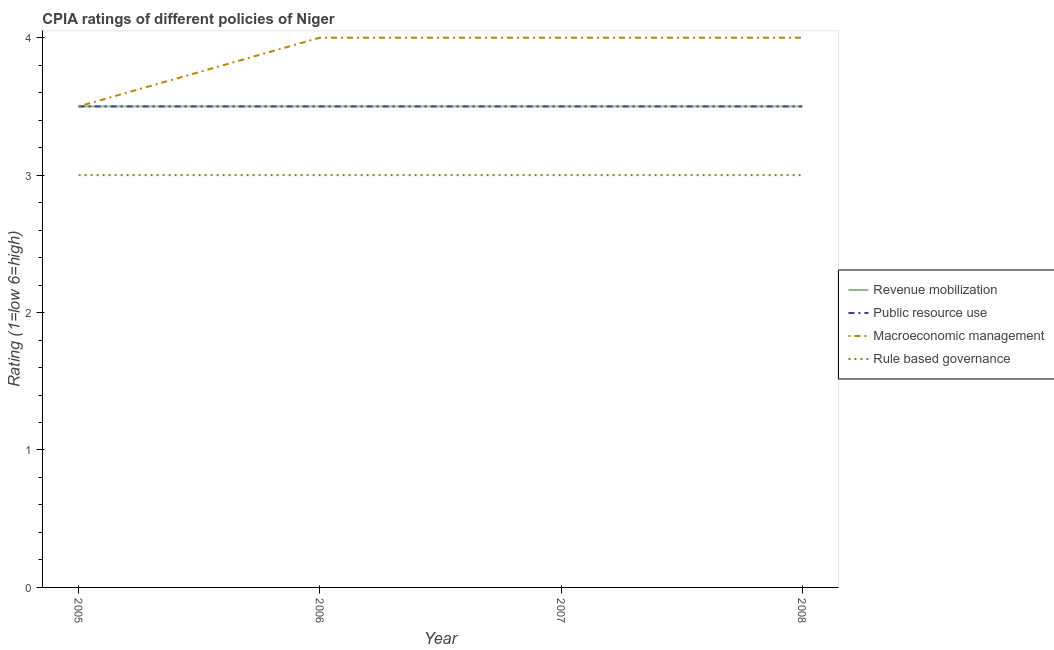How many different coloured lines are there?
Keep it short and to the point. 4. What is the cpia rating of rule based governance in 2007?
Offer a very short reply. 3. Across all years, what is the maximum cpia rating of macroeconomic management?
Keep it short and to the point. 4. What is the difference between the cpia rating of macroeconomic management in 2006 and that in 2008?
Provide a short and direct response. 0. What is the average cpia rating of revenue mobilization per year?
Offer a very short reply. 3.5. In the year 2005, what is the difference between the cpia rating of revenue mobilization and cpia rating of public resource use?
Your answer should be very brief. 0. In how many years, is the cpia rating of macroeconomic management greater than 2.8?
Provide a succinct answer. 4. What is the ratio of the cpia rating of revenue mobilization in 2007 to that in 2008?
Your answer should be very brief. 1. What is the difference between the highest and the second highest cpia rating of macroeconomic management?
Your answer should be compact. 0. Is the sum of the cpia rating of rule based governance in 2006 and 2008 greater than the maximum cpia rating of macroeconomic management across all years?
Your response must be concise. Yes. Is it the case that in every year, the sum of the cpia rating of rule based governance and cpia rating of macroeconomic management is greater than the sum of cpia rating of public resource use and cpia rating of revenue mobilization?
Ensure brevity in your answer.  No. Is it the case that in every year, the sum of the cpia rating of revenue mobilization and cpia rating of public resource use is greater than the cpia rating of macroeconomic management?
Give a very brief answer. Yes. How many lines are there?
Keep it short and to the point. 4. What is the difference between two consecutive major ticks on the Y-axis?
Offer a terse response. 1. Does the graph contain grids?
Offer a terse response. No. How many legend labels are there?
Make the answer very short. 4. What is the title of the graph?
Ensure brevity in your answer.  CPIA ratings of different policies of Niger. What is the Rating (1=low 6=high) in Revenue mobilization in 2005?
Keep it short and to the point. 3.5. What is the Rating (1=low 6=high) in Public resource use in 2005?
Provide a short and direct response. 3.5. What is the Rating (1=low 6=high) of Macroeconomic management in 2005?
Give a very brief answer. 3.5. What is the Rating (1=low 6=high) of Rule based governance in 2005?
Provide a succinct answer. 3. What is the Rating (1=low 6=high) in Revenue mobilization in 2006?
Ensure brevity in your answer.  3.5. What is the Rating (1=low 6=high) of Revenue mobilization in 2007?
Make the answer very short. 3.5. What is the Rating (1=low 6=high) in Public resource use in 2007?
Ensure brevity in your answer.  3.5. What is the Rating (1=low 6=high) of Macroeconomic management in 2007?
Make the answer very short. 4. What is the Rating (1=low 6=high) of Rule based governance in 2007?
Give a very brief answer. 3. What is the Rating (1=low 6=high) in Revenue mobilization in 2008?
Give a very brief answer. 3.5. What is the Rating (1=low 6=high) of Macroeconomic management in 2008?
Make the answer very short. 4. Across all years, what is the maximum Rating (1=low 6=high) in Rule based governance?
Your response must be concise. 3. Across all years, what is the minimum Rating (1=low 6=high) of Revenue mobilization?
Provide a short and direct response. 3.5. Across all years, what is the minimum Rating (1=low 6=high) in Rule based governance?
Provide a short and direct response. 3. What is the difference between the Rating (1=low 6=high) of Rule based governance in 2005 and that in 2006?
Make the answer very short. 0. What is the difference between the Rating (1=low 6=high) in Revenue mobilization in 2005 and that in 2007?
Offer a very short reply. 0. What is the difference between the Rating (1=low 6=high) in Public resource use in 2005 and that in 2007?
Offer a very short reply. 0. What is the difference between the Rating (1=low 6=high) in Revenue mobilization in 2005 and that in 2008?
Make the answer very short. 0. What is the difference between the Rating (1=low 6=high) of Public resource use in 2005 and that in 2008?
Offer a very short reply. 0. What is the difference between the Rating (1=low 6=high) in Rule based governance in 2005 and that in 2008?
Keep it short and to the point. 0. What is the difference between the Rating (1=low 6=high) of Public resource use in 2006 and that in 2007?
Give a very brief answer. 0. What is the difference between the Rating (1=low 6=high) of Rule based governance in 2006 and that in 2008?
Provide a short and direct response. 0. What is the difference between the Rating (1=low 6=high) of Revenue mobilization in 2007 and that in 2008?
Ensure brevity in your answer.  0. What is the difference between the Rating (1=low 6=high) in Public resource use in 2007 and that in 2008?
Your response must be concise. 0. What is the difference between the Rating (1=low 6=high) of Macroeconomic management in 2007 and that in 2008?
Make the answer very short. 0. What is the difference between the Rating (1=low 6=high) in Rule based governance in 2007 and that in 2008?
Keep it short and to the point. 0. What is the difference between the Rating (1=low 6=high) of Revenue mobilization in 2005 and the Rating (1=low 6=high) of Rule based governance in 2006?
Provide a short and direct response. 0.5. What is the difference between the Rating (1=low 6=high) in Public resource use in 2005 and the Rating (1=low 6=high) in Rule based governance in 2006?
Keep it short and to the point. 0.5. What is the difference between the Rating (1=low 6=high) in Macroeconomic management in 2005 and the Rating (1=low 6=high) in Rule based governance in 2006?
Offer a very short reply. 0.5. What is the difference between the Rating (1=low 6=high) in Revenue mobilization in 2005 and the Rating (1=low 6=high) in Public resource use in 2007?
Give a very brief answer. 0. What is the difference between the Rating (1=low 6=high) in Revenue mobilization in 2005 and the Rating (1=low 6=high) in Macroeconomic management in 2007?
Provide a short and direct response. -0.5. What is the difference between the Rating (1=low 6=high) in Revenue mobilization in 2005 and the Rating (1=low 6=high) in Rule based governance in 2007?
Keep it short and to the point. 0.5. What is the difference between the Rating (1=low 6=high) in Public resource use in 2005 and the Rating (1=low 6=high) in Rule based governance in 2007?
Your answer should be very brief. 0.5. What is the difference between the Rating (1=low 6=high) of Macroeconomic management in 2005 and the Rating (1=low 6=high) of Rule based governance in 2007?
Your answer should be compact. 0.5. What is the difference between the Rating (1=low 6=high) of Revenue mobilization in 2005 and the Rating (1=low 6=high) of Public resource use in 2008?
Offer a very short reply. 0. What is the difference between the Rating (1=low 6=high) in Revenue mobilization in 2005 and the Rating (1=low 6=high) in Macroeconomic management in 2008?
Provide a succinct answer. -0.5. What is the difference between the Rating (1=low 6=high) of Revenue mobilization in 2005 and the Rating (1=low 6=high) of Rule based governance in 2008?
Offer a terse response. 0.5. What is the difference between the Rating (1=low 6=high) of Public resource use in 2005 and the Rating (1=low 6=high) of Macroeconomic management in 2008?
Your response must be concise. -0.5. What is the difference between the Rating (1=low 6=high) of Revenue mobilization in 2006 and the Rating (1=low 6=high) of Public resource use in 2007?
Keep it short and to the point. 0. What is the difference between the Rating (1=low 6=high) in Public resource use in 2006 and the Rating (1=low 6=high) in Macroeconomic management in 2007?
Make the answer very short. -0.5. What is the difference between the Rating (1=low 6=high) in Macroeconomic management in 2006 and the Rating (1=low 6=high) in Rule based governance in 2007?
Make the answer very short. 1. What is the difference between the Rating (1=low 6=high) of Revenue mobilization in 2006 and the Rating (1=low 6=high) of Macroeconomic management in 2008?
Ensure brevity in your answer.  -0.5. What is the difference between the Rating (1=low 6=high) of Revenue mobilization in 2006 and the Rating (1=low 6=high) of Rule based governance in 2008?
Provide a succinct answer. 0.5. What is the difference between the Rating (1=low 6=high) of Macroeconomic management in 2006 and the Rating (1=low 6=high) of Rule based governance in 2008?
Your response must be concise. 1. What is the difference between the Rating (1=low 6=high) in Revenue mobilization in 2007 and the Rating (1=low 6=high) in Rule based governance in 2008?
Give a very brief answer. 0.5. What is the difference between the Rating (1=low 6=high) in Public resource use in 2007 and the Rating (1=low 6=high) in Rule based governance in 2008?
Make the answer very short. 0.5. What is the average Rating (1=low 6=high) in Revenue mobilization per year?
Your answer should be compact. 3.5. What is the average Rating (1=low 6=high) in Public resource use per year?
Keep it short and to the point. 3.5. What is the average Rating (1=low 6=high) of Macroeconomic management per year?
Your answer should be compact. 3.88. What is the average Rating (1=low 6=high) in Rule based governance per year?
Ensure brevity in your answer.  3. In the year 2005, what is the difference between the Rating (1=low 6=high) in Revenue mobilization and Rating (1=low 6=high) in Rule based governance?
Provide a short and direct response. 0.5. In the year 2006, what is the difference between the Rating (1=low 6=high) in Revenue mobilization and Rating (1=low 6=high) in Public resource use?
Make the answer very short. 0. In the year 2006, what is the difference between the Rating (1=low 6=high) of Revenue mobilization and Rating (1=low 6=high) of Rule based governance?
Offer a very short reply. 0.5. In the year 2006, what is the difference between the Rating (1=low 6=high) in Public resource use and Rating (1=low 6=high) in Macroeconomic management?
Offer a terse response. -0.5. In the year 2006, what is the difference between the Rating (1=low 6=high) in Macroeconomic management and Rating (1=low 6=high) in Rule based governance?
Make the answer very short. 1. In the year 2007, what is the difference between the Rating (1=low 6=high) of Public resource use and Rating (1=low 6=high) of Rule based governance?
Make the answer very short. 0.5. In the year 2008, what is the difference between the Rating (1=low 6=high) in Public resource use and Rating (1=low 6=high) in Rule based governance?
Your answer should be compact. 0.5. What is the ratio of the Rating (1=low 6=high) of Public resource use in 2005 to that in 2006?
Provide a short and direct response. 1. What is the ratio of the Rating (1=low 6=high) in Macroeconomic management in 2005 to that in 2006?
Your response must be concise. 0.88. What is the ratio of the Rating (1=low 6=high) of Rule based governance in 2005 to that in 2006?
Your response must be concise. 1. What is the ratio of the Rating (1=low 6=high) of Revenue mobilization in 2005 to that in 2007?
Your response must be concise. 1. What is the ratio of the Rating (1=low 6=high) of Macroeconomic management in 2005 to that in 2007?
Your answer should be very brief. 0.88. What is the ratio of the Rating (1=low 6=high) in Rule based governance in 2005 to that in 2008?
Ensure brevity in your answer.  1. What is the ratio of the Rating (1=low 6=high) in Revenue mobilization in 2006 to that in 2007?
Provide a short and direct response. 1. What is the ratio of the Rating (1=low 6=high) in Public resource use in 2006 to that in 2007?
Offer a terse response. 1. What is the ratio of the Rating (1=low 6=high) in Macroeconomic management in 2006 to that in 2007?
Your answer should be compact. 1. What is the ratio of the Rating (1=low 6=high) in Revenue mobilization in 2006 to that in 2008?
Give a very brief answer. 1. What is the ratio of the Rating (1=low 6=high) of Public resource use in 2006 to that in 2008?
Provide a succinct answer. 1. What is the ratio of the Rating (1=low 6=high) of Revenue mobilization in 2007 to that in 2008?
Your response must be concise. 1. What is the ratio of the Rating (1=low 6=high) in Public resource use in 2007 to that in 2008?
Give a very brief answer. 1. What is the ratio of the Rating (1=low 6=high) in Rule based governance in 2007 to that in 2008?
Offer a very short reply. 1. What is the difference between the highest and the second highest Rating (1=low 6=high) of Revenue mobilization?
Provide a short and direct response. 0. What is the difference between the highest and the second highest Rating (1=low 6=high) of Public resource use?
Make the answer very short. 0. What is the difference between the highest and the second highest Rating (1=low 6=high) in Macroeconomic management?
Offer a terse response. 0. What is the difference between the highest and the lowest Rating (1=low 6=high) in Revenue mobilization?
Your response must be concise. 0. What is the difference between the highest and the lowest Rating (1=low 6=high) of Macroeconomic management?
Your answer should be very brief. 0.5. 